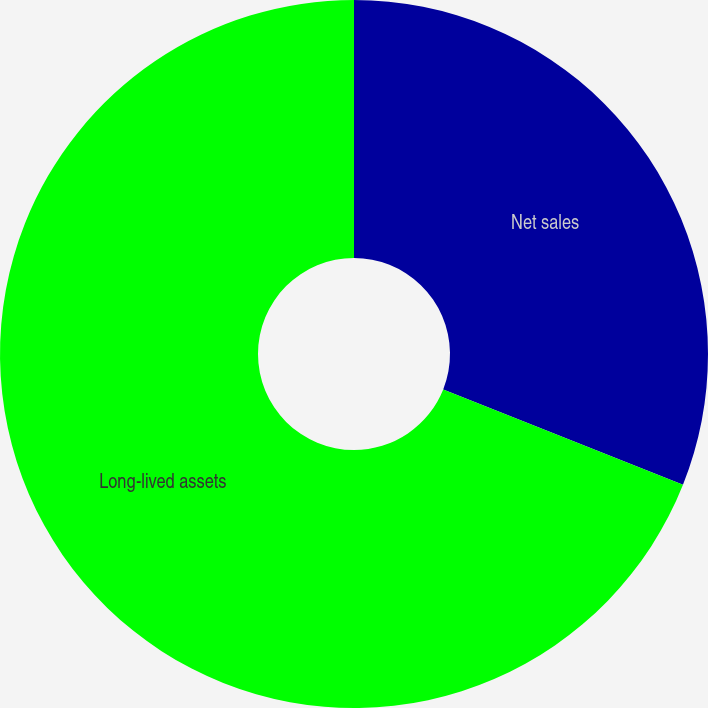Convert chart. <chart><loc_0><loc_0><loc_500><loc_500><pie_chart><fcel>Net sales<fcel>Long-lived assets<nl><fcel>31.02%<fcel>68.98%<nl></chart> 